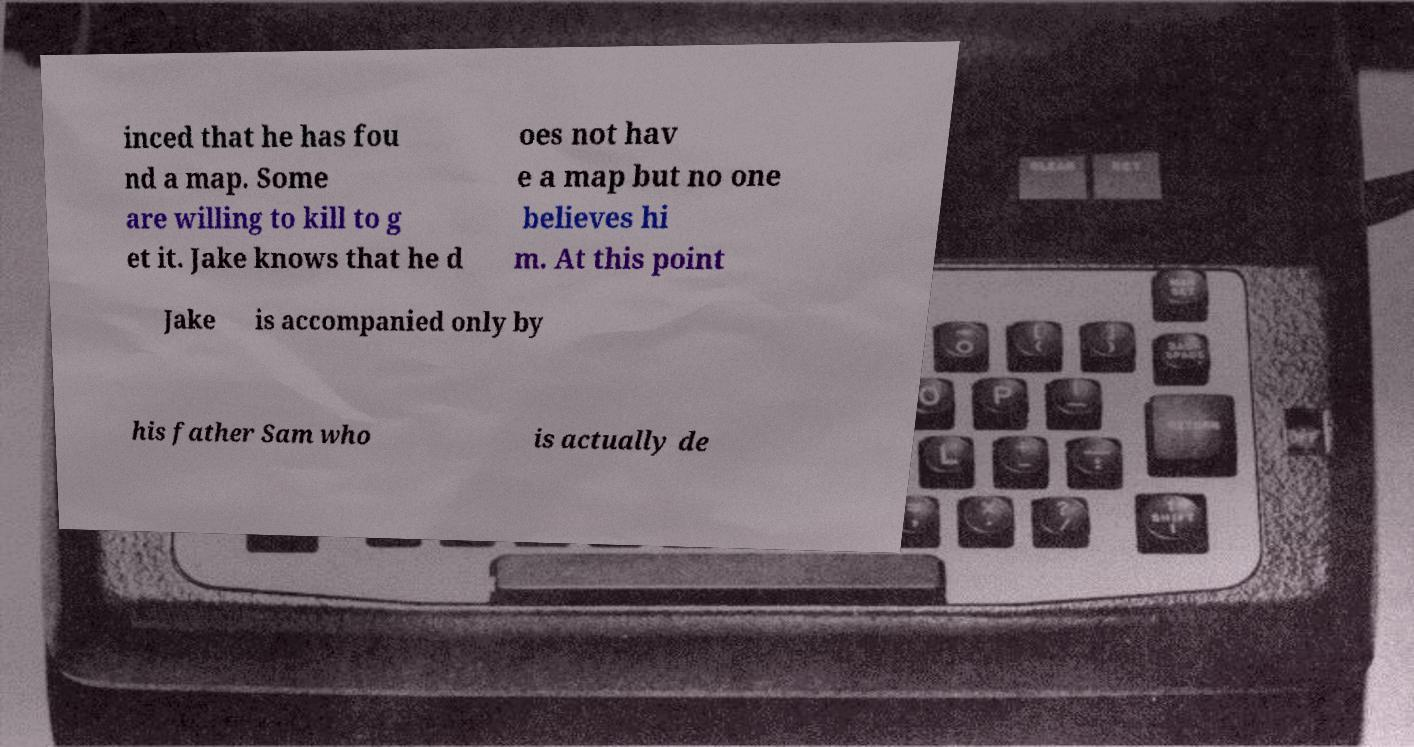Could you extract and type out the text from this image? inced that he has fou nd a map. Some are willing to kill to g et it. Jake knows that he d oes not hav e a map but no one believes hi m. At this point Jake is accompanied only by his father Sam who is actually de 